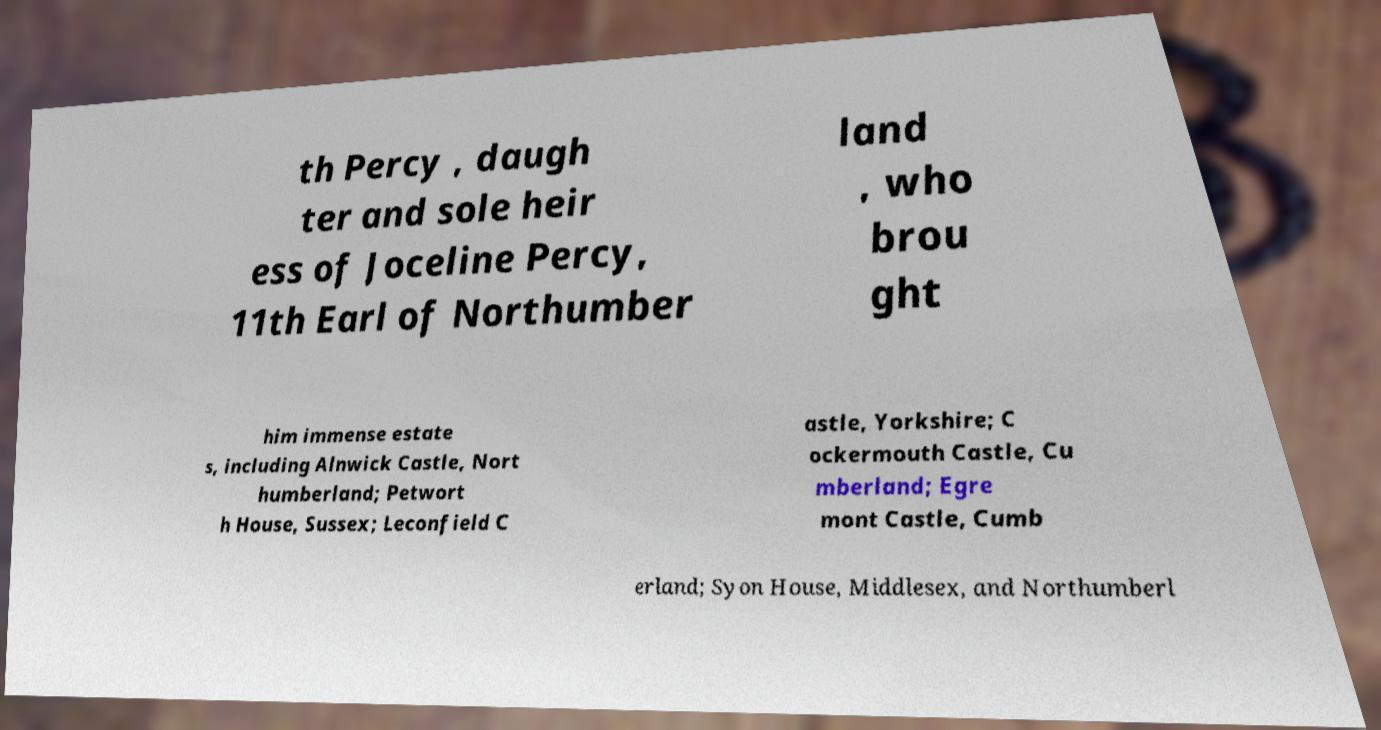What messages or text are displayed in this image? I need them in a readable, typed format. th Percy , daugh ter and sole heir ess of Joceline Percy, 11th Earl of Northumber land , who brou ght him immense estate s, including Alnwick Castle, Nort humberland; Petwort h House, Sussex; Leconfield C astle, Yorkshire; C ockermouth Castle, Cu mberland; Egre mont Castle, Cumb erland; Syon House, Middlesex, and Northumberl 